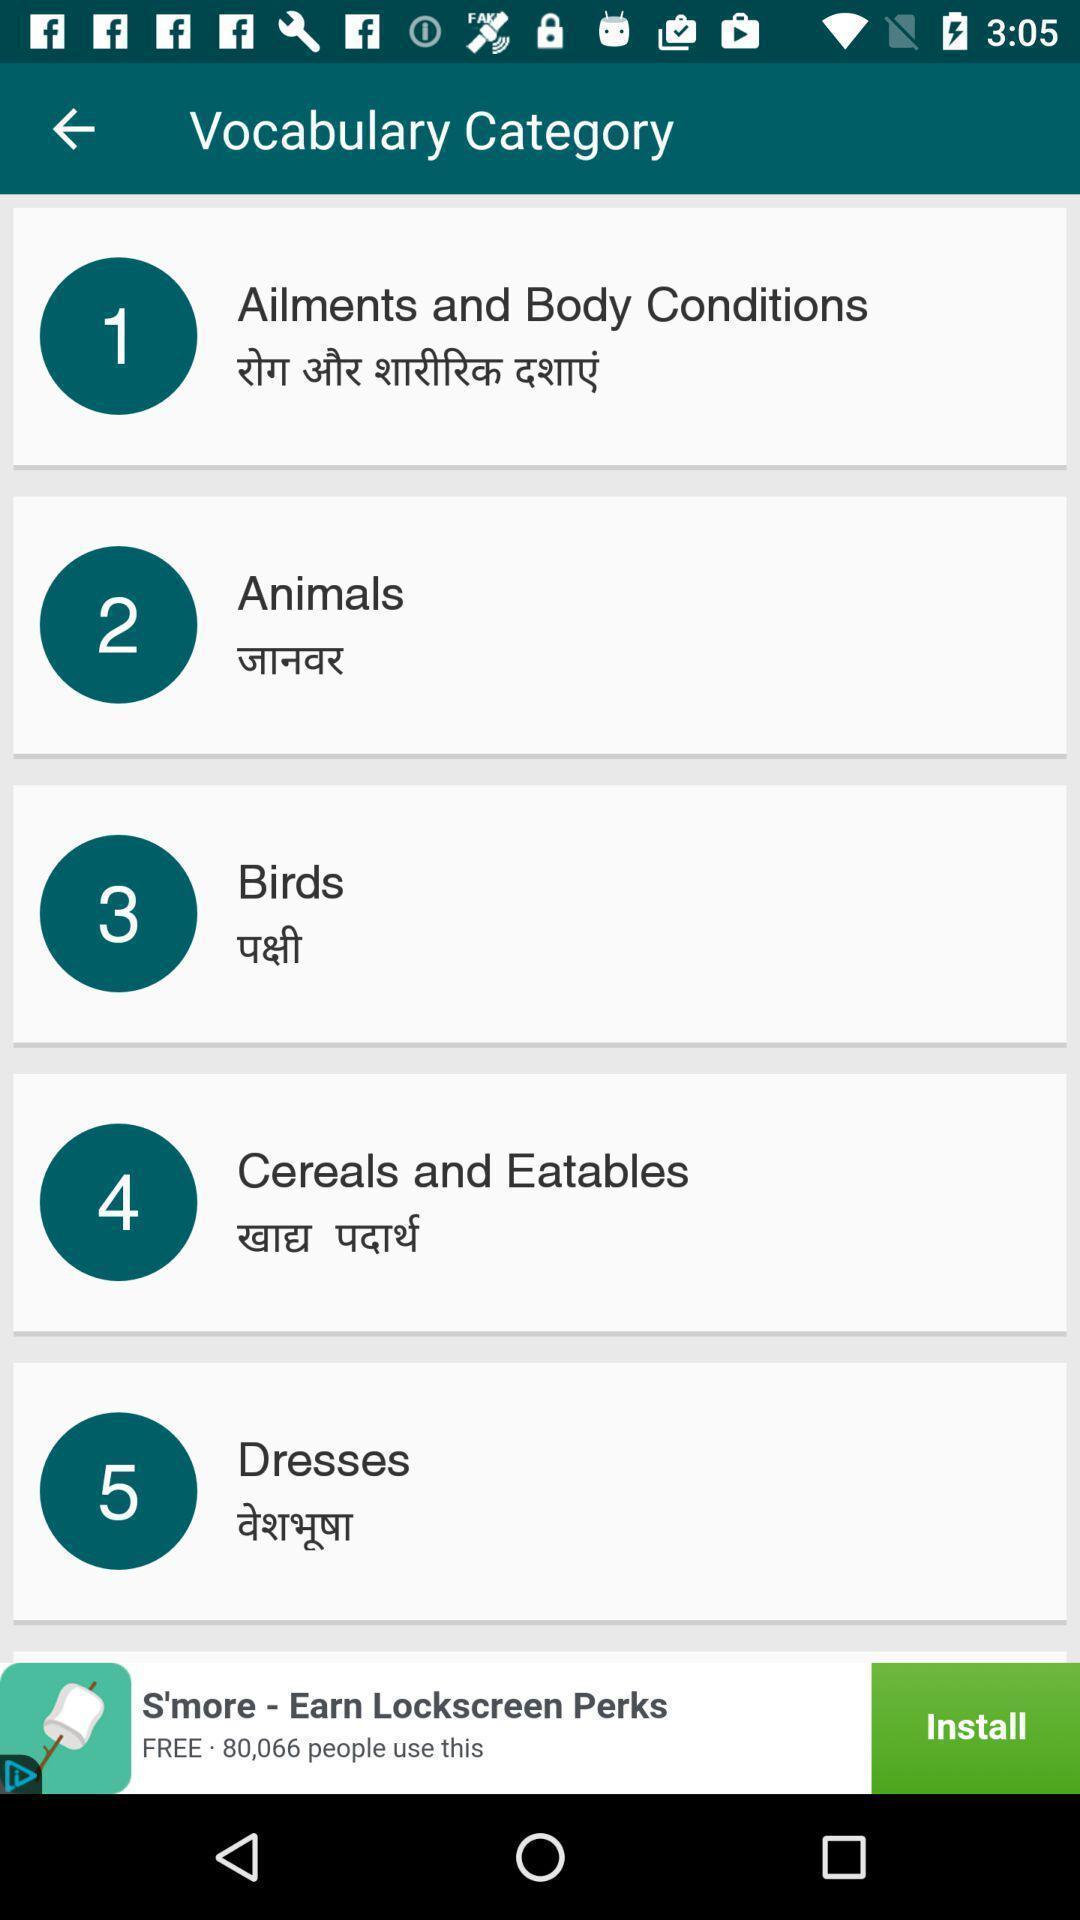Tell me what you see in this picture. Page showing content in a language learning app. 